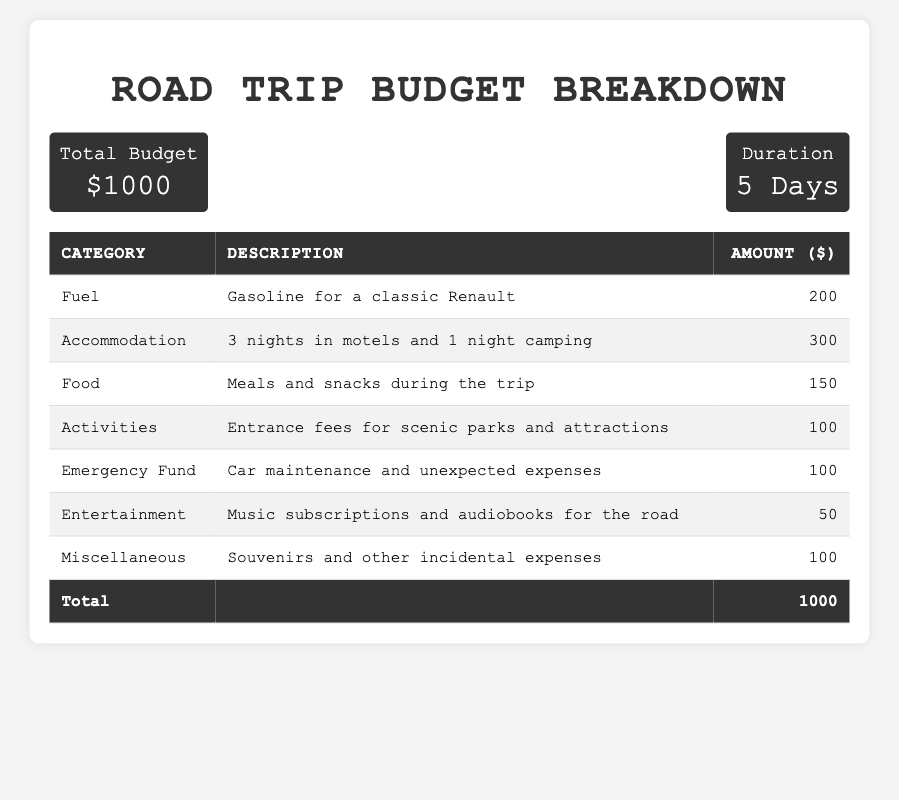What is the total budget for the trip? The total budget is explicitly mentioned in the table under the "Total Budget" section, which shows $1000.
Answer: $1000 How much is allocated for Fuel? The table lists the Fuel expense under the "Expenses" section, showing an amount of $200 allocated for gasoline.
Answer: $200 What is the total amount spent on Accommodation? The Accommodation expense is specified in the table as $300 for 3 nights in motels and 1 night camping.
Answer: $300 How much money is set aside for Food expenses? The "Food" expense in the table indicates that a total of $150 is budgeted for meals and snacks during the trip.
Answer: $150 What is the amount for Emergency Fund? The "Emergency Fund" category in the table indicates $100 set aside for car maintenance and unexpected expenses.
Answer: $100 Is the amount for Entertainment more than the amount for Activities? The table shows $50 for Entertainment and $100 for Activities, so no, Entertainment is less than Activities.
Answer: No How much did you spend in total for Activities and Food combined? To find this, add the amounts: Activities ($100) + Food ($150) = $250 total spent on both categories.
Answer: $250 What is the percentage of the total budget spent on Fuel? Calculate the percentage by dividing the Fuel expense ($200) by the total budget ($1000) and then multiplying by 100: ($200/$1000) × 100 = 20%.
Answer: 20% If the total budget is $1000, what is the remaining amount after subtracting Fuel, Food, and Accommodation expenses? First, sum the expenses for Fuel ($200), Food ($150), and Accommodation ($300): $200 + $150 + $300 = $650. Then, subtract this from the total budget: $1000 - $650 = $350 remaining.
Answer: $350 What is the total amount allocated for Miscellaneous and Entertainment? To find the total, add the Miscellaneous amount ($100) and Entertainment amount ($50): $100 + $50 = $150.
Answer: $150 How many categories have expenses of $100 or more? The table lists three categories with expenses of $100 or more: Accommodation ($300), Activities ($100), and Emergency Fund ($100). Thus, there are 3 categories.
Answer: 3 If you wanted to reduce the fuel budget by 25%, what would the new fuel budget be? First, calculate 25% of the current Fuel budget ($200): 0.25 × $200 = $50. Then, subtract this from the original Fuel budget: $200 - $50 = $150.
Answer: $150 